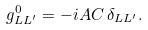<formula> <loc_0><loc_0><loc_500><loc_500>g ^ { 0 } _ { L L ^ { \prime } } = - i A C \, \delta _ { L L ^ { \prime } } .</formula> 